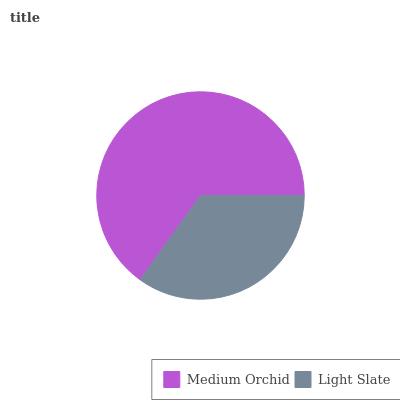Is Light Slate the minimum?
Answer yes or no. Yes. Is Medium Orchid the maximum?
Answer yes or no. Yes. Is Light Slate the maximum?
Answer yes or no. No. Is Medium Orchid greater than Light Slate?
Answer yes or no. Yes. Is Light Slate less than Medium Orchid?
Answer yes or no. Yes. Is Light Slate greater than Medium Orchid?
Answer yes or no. No. Is Medium Orchid less than Light Slate?
Answer yes or no. No. Is Medium Orchid the high median?
Answer yes or no. Yes. Is Light Slate the low median?
Answer yes or no. Yes. Is Light Slate the high median?
Answer yes or no. No. Is Medium Orchid the low median?
Answer yes or no. No. 